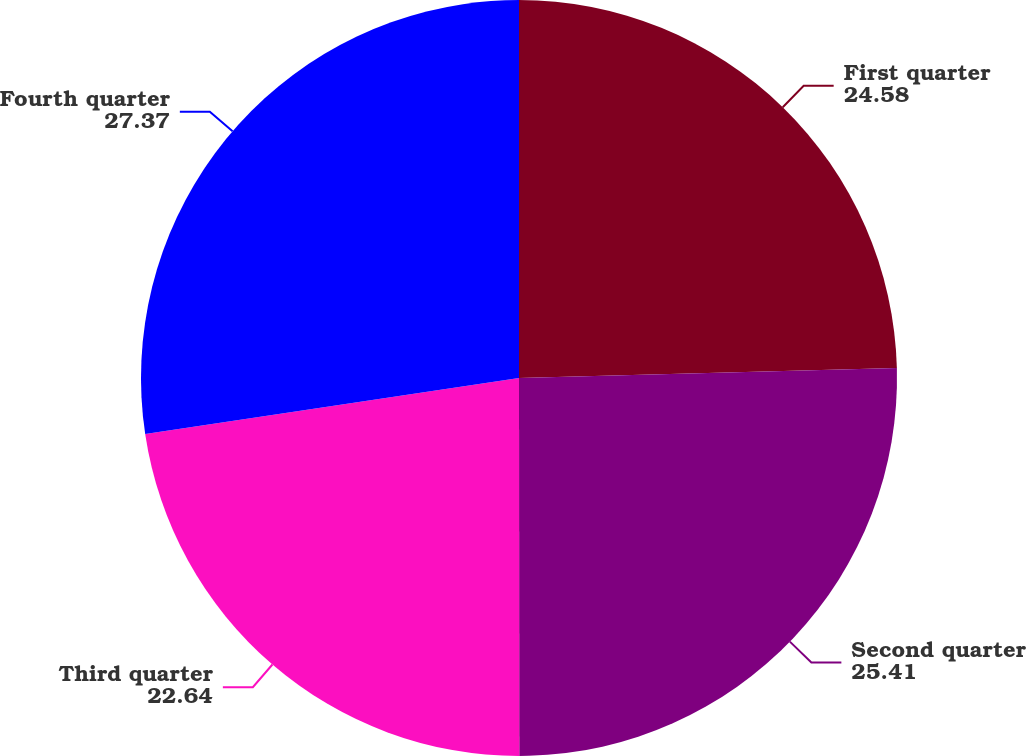<chart> <loc_0><loc_0><loc_500><loc_500><pie_chart><fcel>First quarter<fcel>Second quarter<fcel>Third quarter<fcel>Fourth quarter<nl><fcel>24.58%<fcel>25.41%<fcel>22.64%<fcel>27.37%<nl></chart> 